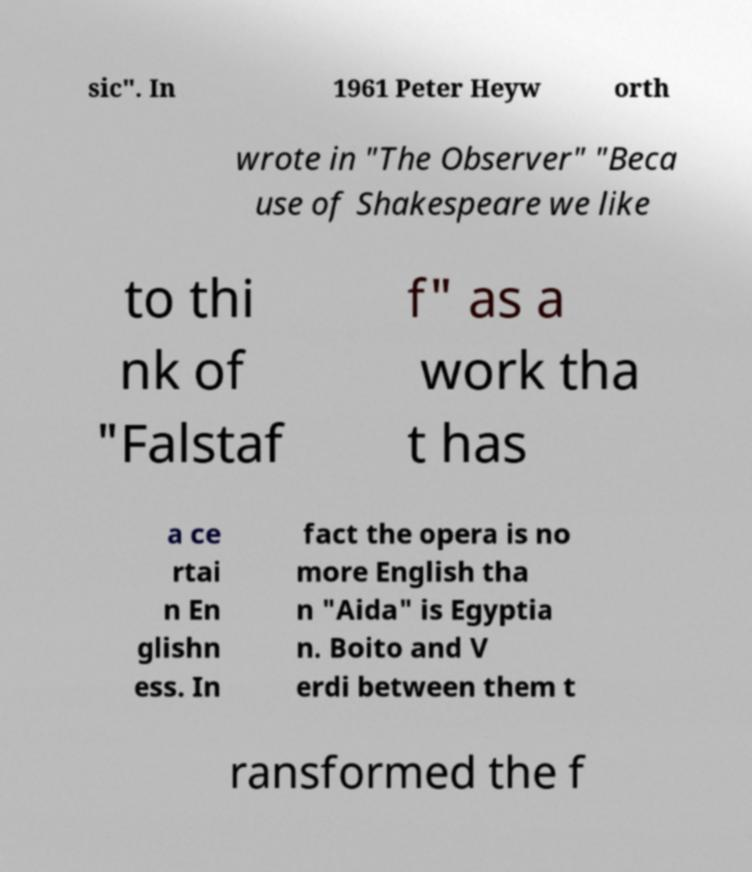What messages or text are displayed in this image? I need them in a readable, typed format. sic". In 1961 Peter Heyw orth wrote in "The Observer" "Beca use of Shakespeare we like to thi nk of "Falstaf f" as a work tha t has a ce rtai n En glishn ess. In fact the opera is no more English tha n "Aida" is Egyptia n. Boito and V erdi between them t ransformed the f 